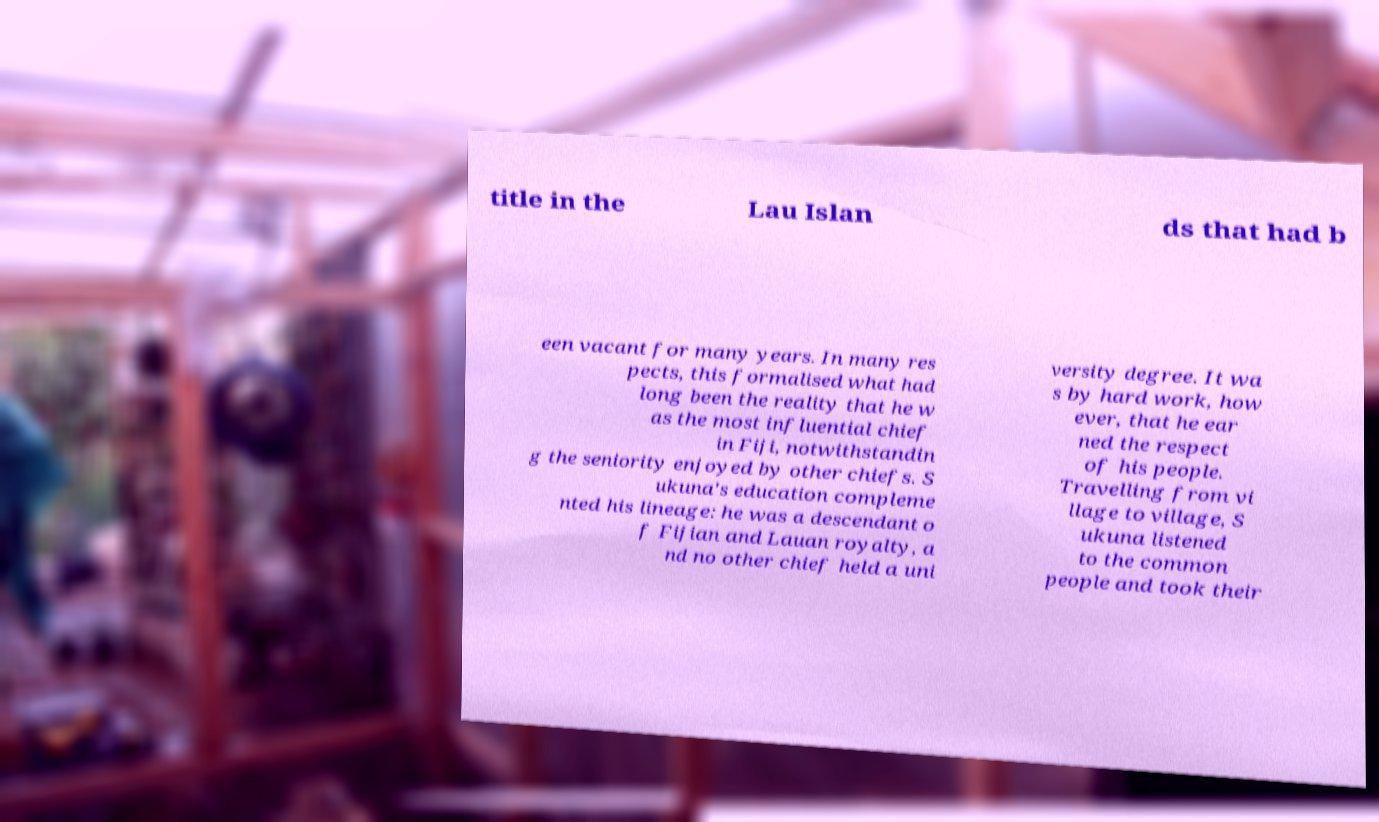Please read and relay the text visible in this image. What does it say? title in the Lau Islan ds that had b een vacant for many years. In many res pects, this formalised what had long been the reality that he w as the most influential chief in Fiji, notwithstandin g the seniority enjoyed by other chiefs. S ukuna's education compleme nted his lineage: he was a descendant o f Fijian and Lauan royalty, a nd no other chief held a uni versity degree. It wa s by hard work, how ever, that he ear ned the respect of his people. Travelling from vi llage to village, S ukuna listened to the common people and took their 